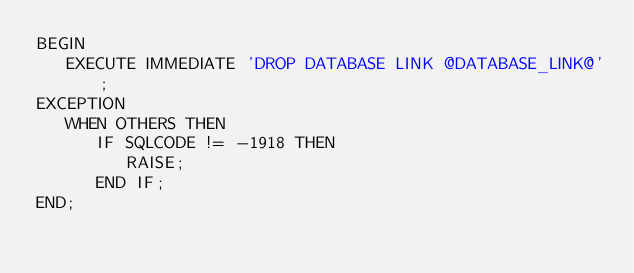Convert code to text. <code><loc_0><loc_0><loc_500><loc_500><_SQL_>BEGIN
   EXECUTE IMMEDIATE 'DROP DATABASE LINK @DATABASE_LINK@';
EXCEPTION
   WHEN OTHERS THEN
      IF SQLCODE != -1918 THEN
         RAISE;
      END IF;
END;
</code> 